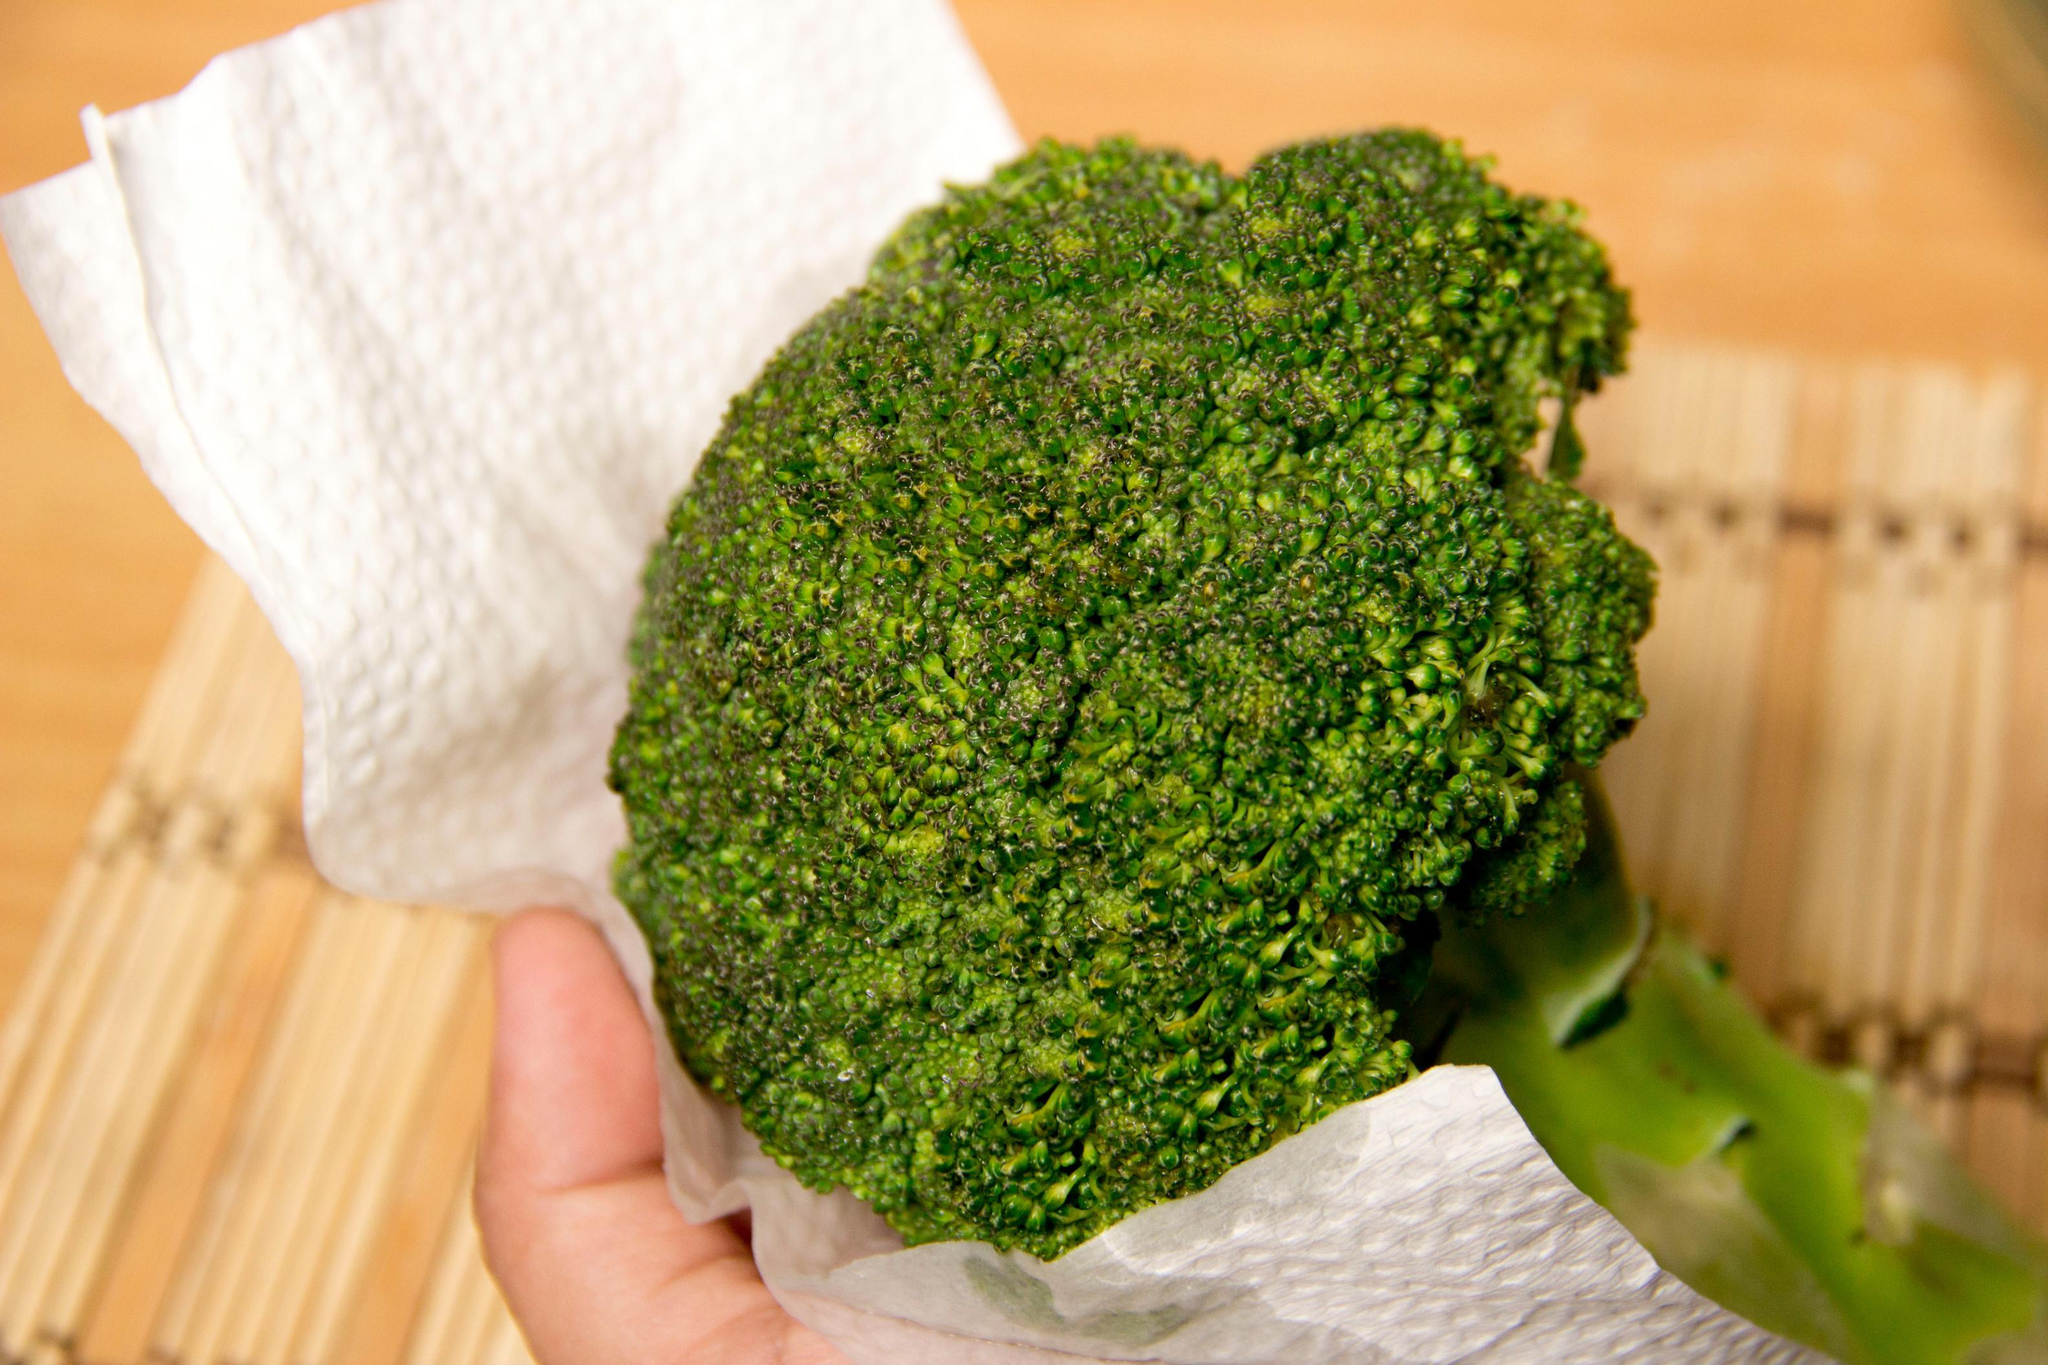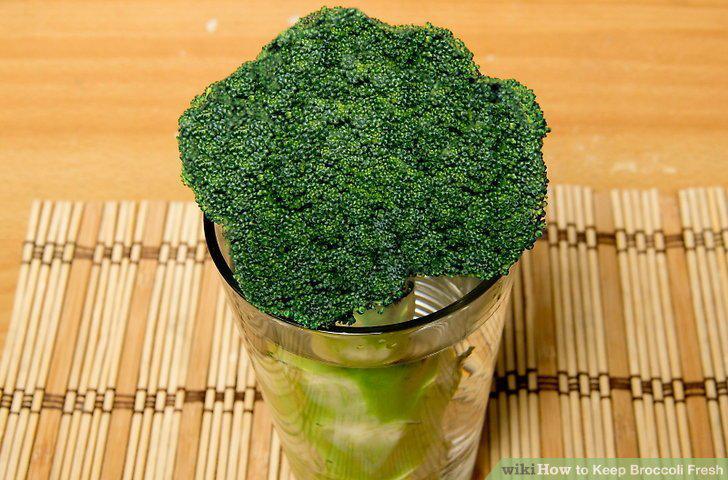The first image is the image on the left, the second image is the image on the right. Given the left and right images, does the statement "The right image shows a stalk of broccoli inside of a cup." hold true? Answer yes or no. Yes. 